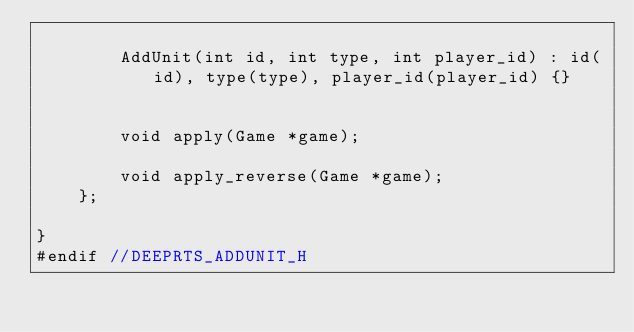Convert code to text. <code><loc_0><loc_0><loc_500><loc_500><_C_>
        AddUnit(int id, int type, int player_id) : id(id), type(type), player_id(player_id) {}


        void apply(Game *game);

        void apply_reverse(Game *game);
    };

}
#endif //DEEPRTS_ADDUNIT_H
</code> 